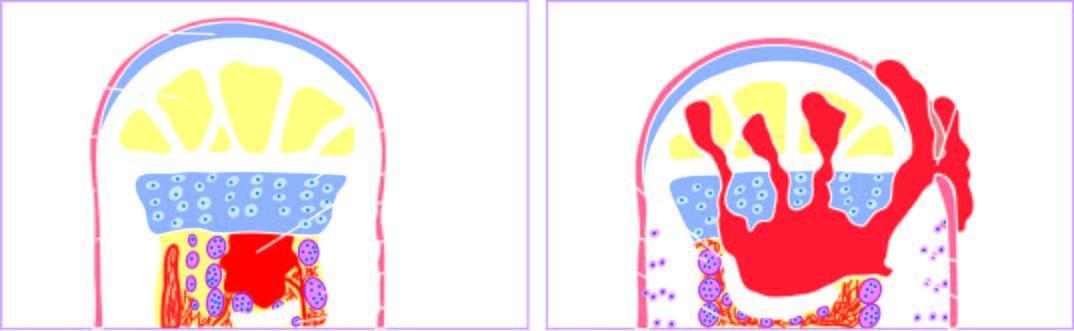what is there of reactive woven bone formation by the periosteum?
Answer the question using a single word or phrase. Beginning 